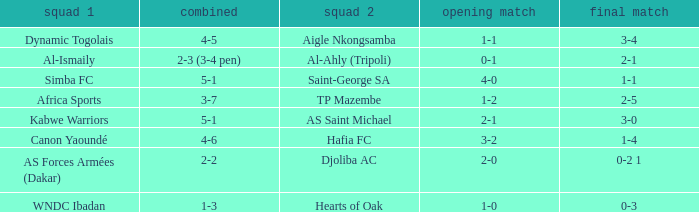When Kabwe Warriors (team 1) played, what was the result of the 1st leg? 2-1. 